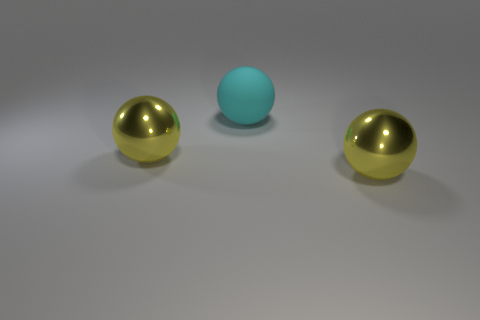What number of small objects are either rubber balls or blue metallic things?
Offer a very short reply. 0. Is there any other thing that has the same color as the big rubber ball?
Your answer should be very brief. No. Are the large yellow sphere to the left of the cyan matte sphere and the cyan sphere made of the same material?
Your response must be concise. No. Are there any other things that are the same material as the big cyan thing?
Give a very brief answer. No. There is a yellow sphere that is left of the yellow metal object that is to the right of the cyan matte sphere; what number of large matte things are in front of it?
Provide a short and direct response. 0. There is a object that is right of the rubber ball; is it the same shape as the matte thing?
Offer a very short reply. Yes. What number of things are either metallic cylinders or large metallic balls on the right side of the rubber sphere?
Keep it short and to the point. 1. Are there more big metallic balls to the left of the cyan matte object than things?
Give a very brief answer. No. Are there any metallic spheres that are behind the yellow metal sphere on the right side of the large cyan matte ball?
Offer a very short reply. Yes. There is a shiny sphere behind the large yellow sphere on the right side of the big rubber object; what is its size?
Provide a short and direct response. Large. 